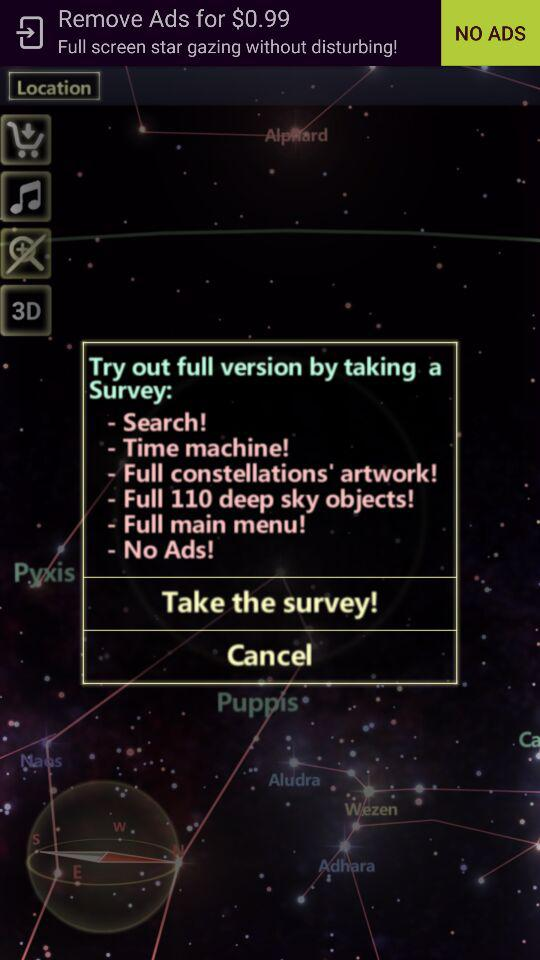How many features are offered in the full version?
Answer the question using a single word or phrase. 6 